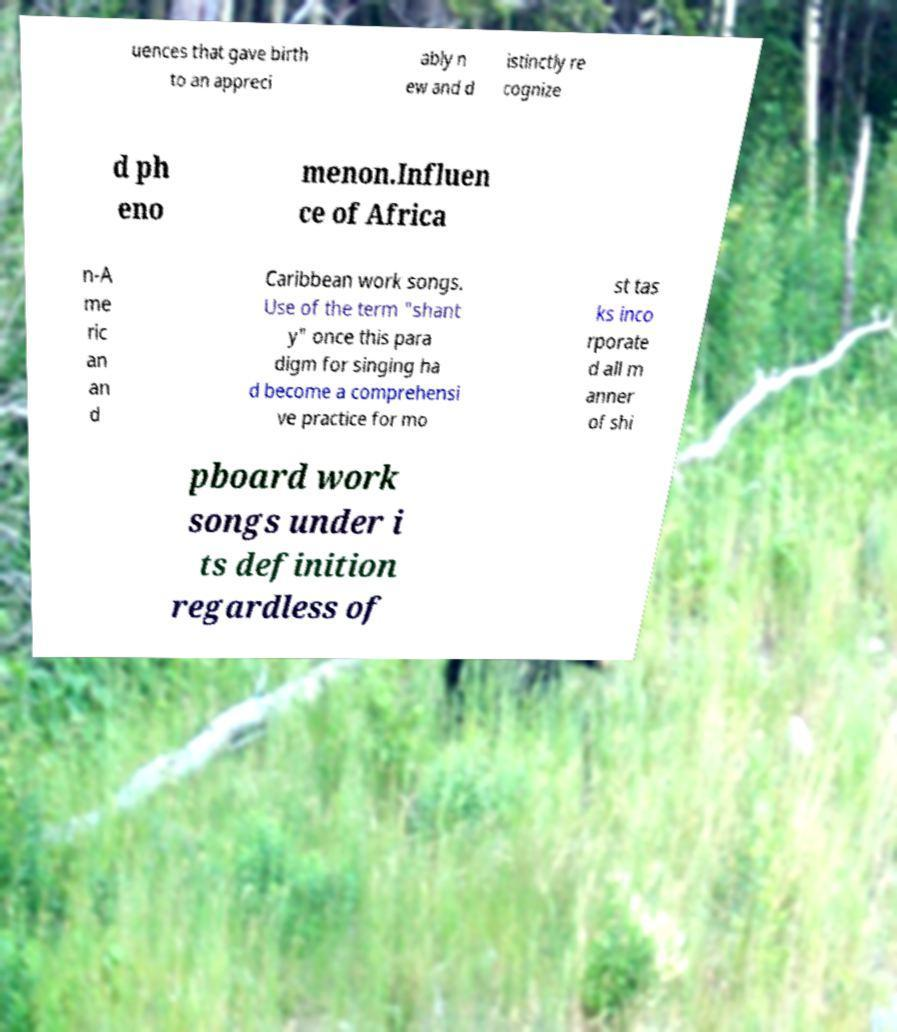Can you accurately transcribe the text from the provided image for me? uences that gave birth to an appreci ably n ew and d istinctly re cognize d ph eno menon.Influen ce of Africa n-A me ric an an d Caribbean work songs. Use of the term "shant y" once this para digm for singing ha d become a comprehensi ve practice for mo st tas ks inco rporate d all m anner of shi pboard work songs under i ts definition regardless of 